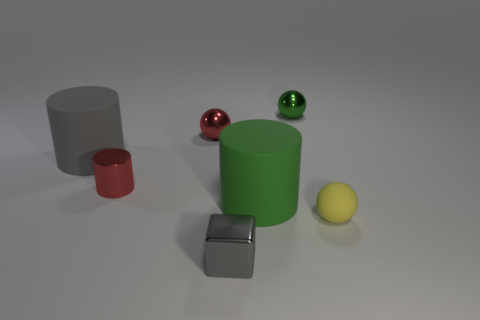Add 2 big brown blocks. How many objects exist? 9 Subtract all cylinders. How many objects are left? 4 Add 5 tiny blue cylinders. How many tiny blue cylinders exist? 5 Subtract 0 gray balls. How many objects are left? 7 Subtract all rubber spheres. Subtract all yellow matte spheres. How many objects are left? 5 Add 4 green matte objects. How many green matte objects are left? 5 